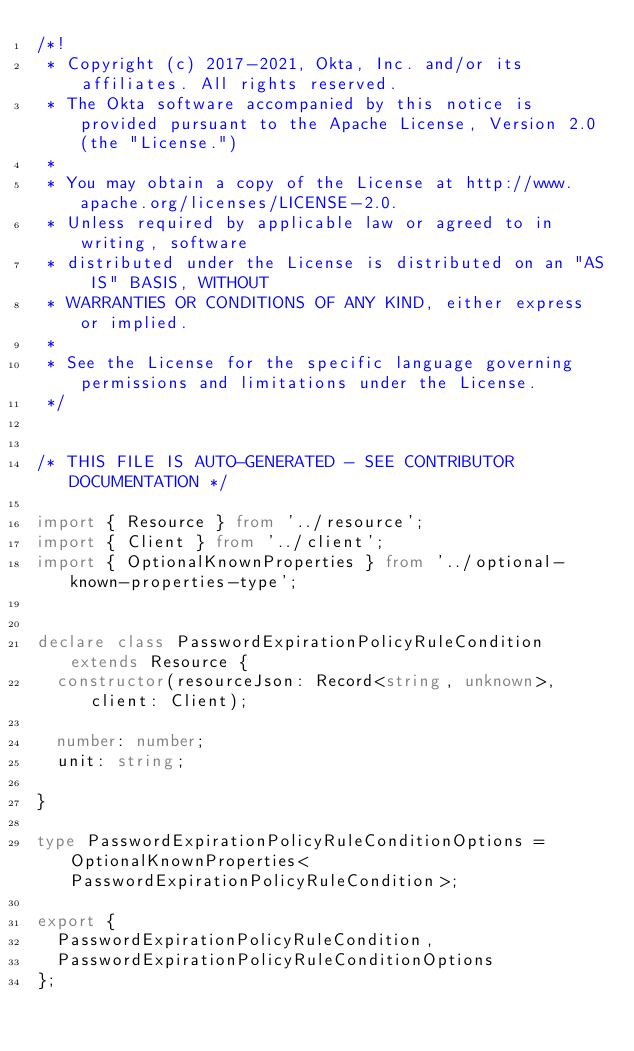Convert code to text. <code><loc_0><loc_0><loc_500><loc_500><_TypeScript_>/*!
 * Copyright (c) 2017-2021, Okta, Inc. and/or its affiliates. All rights reserved.
 * The Okta software accompanied by this notice is provided pursuant to the Apache License, Version 2.0 (the "License.")
 *
 * You may obtain a copy of the License at http://www.apache.org/licenses/LICENSE-2.0.
 * Unless required by applicable law or agreed to in writing, software
 * distributed under the License is distributed on an "AS IS" BASIS, WITHOUT
 * WARRANTIES OR CONDITIONS OF ANY KIND, either express or implied.
 *
 * See the License for the specific language governing permissions and limitations under the License.
 */


/* THIS FILE IS AUTO-GENERATED - SEE CONTRIBUTOR DOCUMENTATION */

import { Resource } from '../resource';
import { Client } from '../client';
import { OptionalKnownProperties } from '../optional-known-properties-type';


declare class PasswordExpirationPolicyRuleCondition extends Resource {
  constructor(resourceJson: Record<string, unknown>, client: Client);

  number: number;
  unit: string;

}

type PasswordExpirationPolicyRuleConditionOptions = OptionalKnownProperties<PasswordExpirationPolicyRuleCondition>;

export {
  PasswordExpirationPolicyRuleCondition,
  PasswordExpirationPolicyRuleConditionOptions
};
</code> 